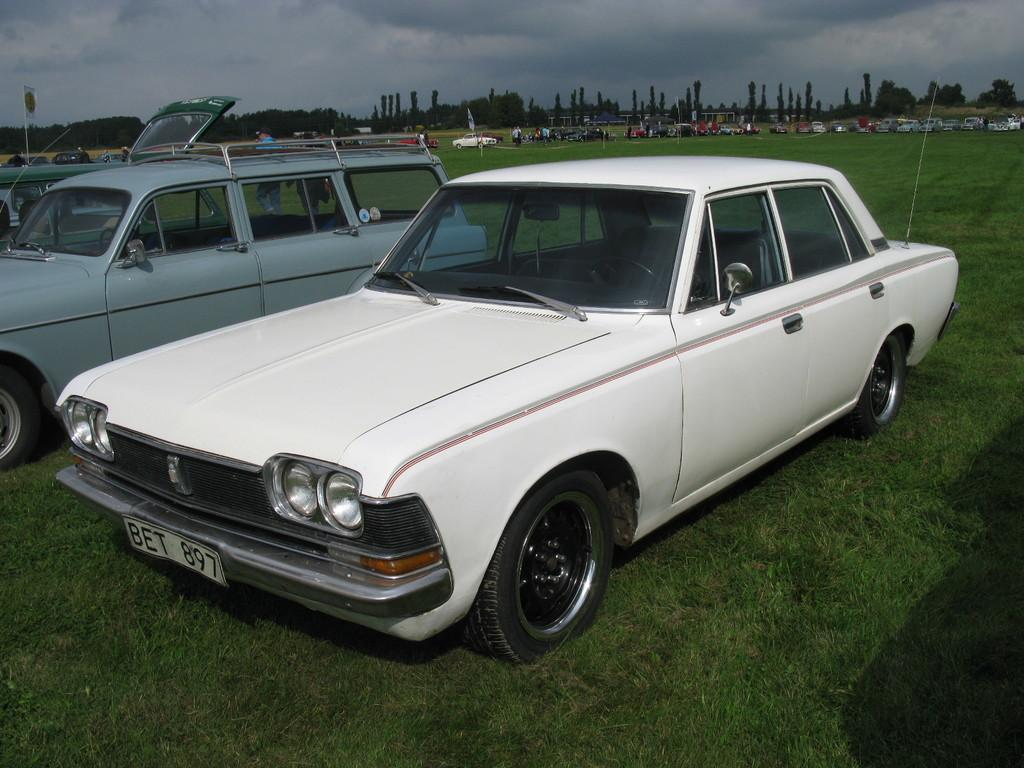How many vehicles are on the grass in the image? There are three vehicles on the grass in the image. Can you describe the vehicles in the background of the image? There are vehicles in the background of the image, but their specific details are not mentioned in the facts. What else can be seen in the background of the image? In the background of the image, there are people, poles, trees, and clouds in the sky. What grade is the floor in the image? There is no mention of a floor in the image, so it is not possible to determine its grade. 